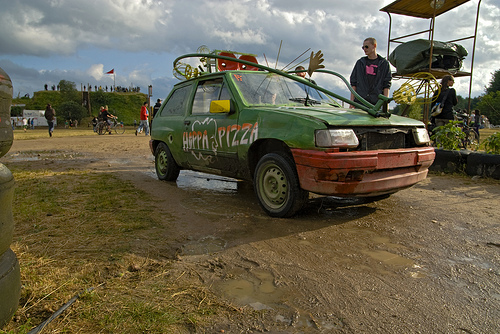<image>
Is the car next to the man? Yes. The car is positioned adjacent to the man, located nearby in the same general area. 